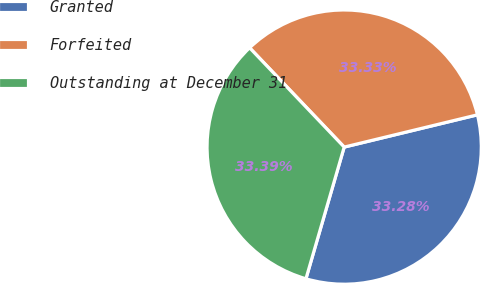Convert chart to OTSL. <chart><loc_0><loc_0><loc_500><loc_500><pie_chart><fcel>Granted<fcel>Forfeited<fcel>Outstanding at December 31<nl><fcel>33.28%<fcel>33.33%<fcel>33.39%<nl></chart> 